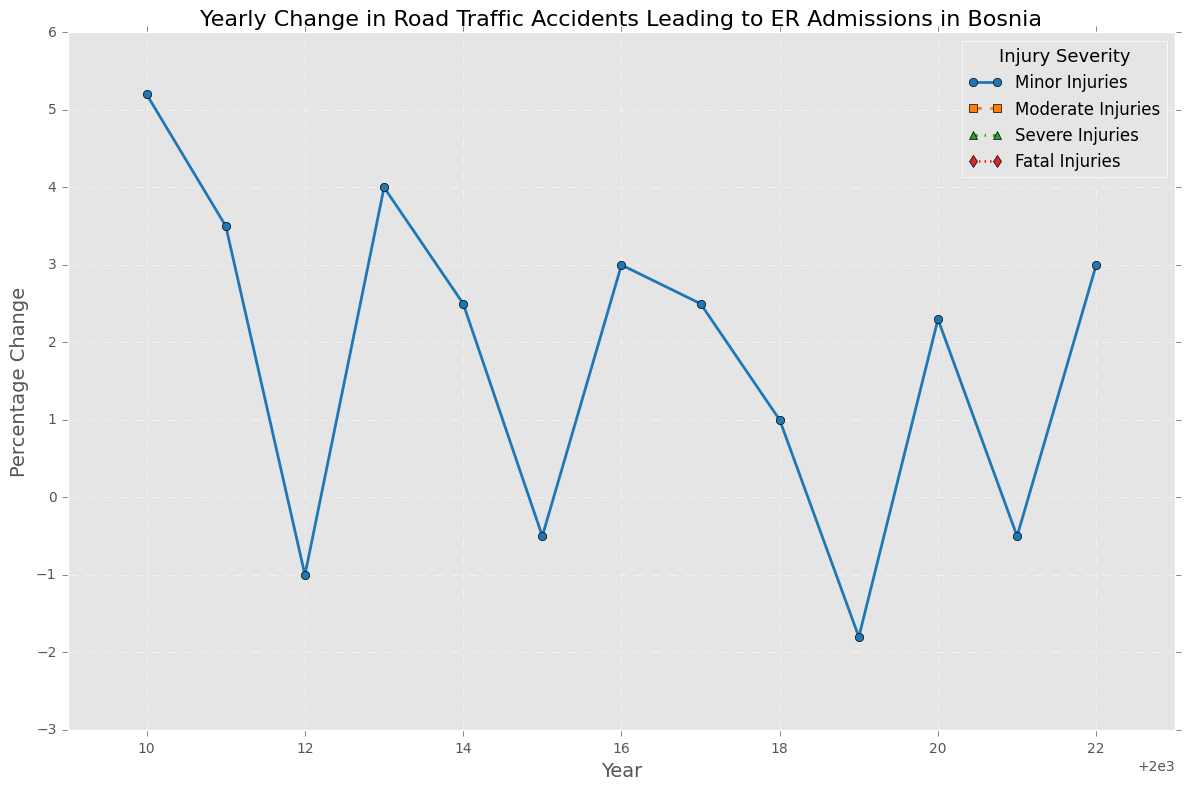What was the year with the highest increase in moderate injuries? The line for moderate injuries shows the highest peak in 2018. In 2018, the percentage change for moderate injuries was 3.0%, which is the highest increase observed in the figure.
Answer: 2018 Was there any year where the severe injuries saw a negative trend two years in a row? Observing the severe injuries line, we notice that 2010-2011 and 2014-2015 both show continuous negative values. Specifically, the line decreased from -1.0% in 2010 to -0.5% in 2011 and from -0.7% in 2014 to -0.4% in 2015.
Answer: Yes Which year experienced the sharpest decline in minor injuries? The steepest downward change in the line for minor injuries appears between 2010 and 2012. In 2010 the value was 5.2%, and in 2012 it was -1.0%. The sharp decline was between 2010 and 2012 where it decreased by a total of 6.2 percentage points.
Answer: 2012 In which year did fatal injuries have the smallest negative change? The line for fatal injuries shows the smallest (closest to zero) negative change in 2011 and 2017, where the value reached -0.1% both years.
Answer: 2011 and 2017 Compare the trend of moderate injuries to severe injuries from 2016 to 2018. From 2016 to 2018, moderate injuries show an initial slight decline in 2016 (-0.3%), followed by an increase in 2017 (0.7%) and a sharp rise in 2018 (3.0%). Severe injuries start with a slight positive change in 2016 (0.2%) and continue to grow in 2017 (0.5%) and further in 2018 (1.0%). Overall, both lines show a positive trend, but moderate injuries have a sharper increase by 2018.
Answer: Moderate injuries showed a sharper increase than severe injuries What was the overall trend in minor injuries from 2018 to 2022? In 2018, minor injuries had a value of 1.0%. This increased to a peak of 2.3% in 2020, then dropped slightly to -0.5% in 2021, ending with a recovery to 3.0% in 2022. The general trend for minor injuries from 2018 to 2022 is positive, with fluctuations.
Answer: Positive trend with fluctuations Did fatal injuries ever reach positive values? Observing the line chart, fatal injuries consistently display negative or zero values. The closest to positive was 2019, with a value of 0.1%, but it never reached a positive percentage.
Answer: No In which year did moderate injuries and severe injuries both experience a positive percentage change? Scanning through the lines for both moderate injuries and severe injuries, we see that in 2012 and 2018, both categories had positive percentage values. In 2012, moderate injuries were 2.5%, and severe injuries were 0.3%. In 2018, moderate injuries were 3.0%, and severe injuries were 1.0%.
Answer: 2012 and 2018 